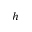<formula> <loc_0><loc_0><loc_500><loc_500>h</formula> 